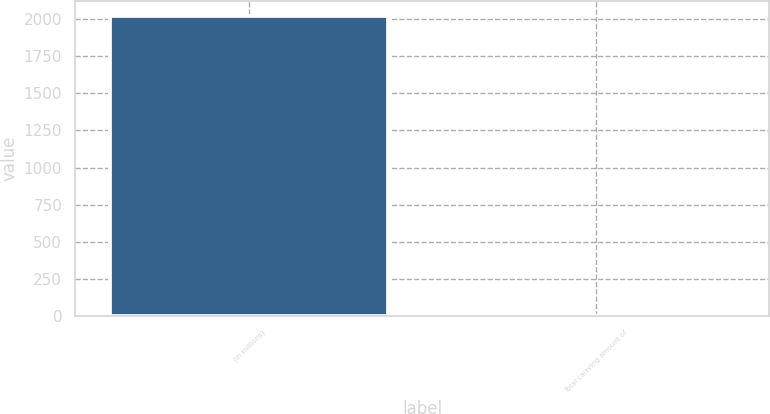<chart> <loc_0><loc_0><loc_500><loc_500><bar_chart><fcel>(in millions)<fcel>Total carrying amount of<nl><fcel>2018<fcel>4.1<nl></chart> 